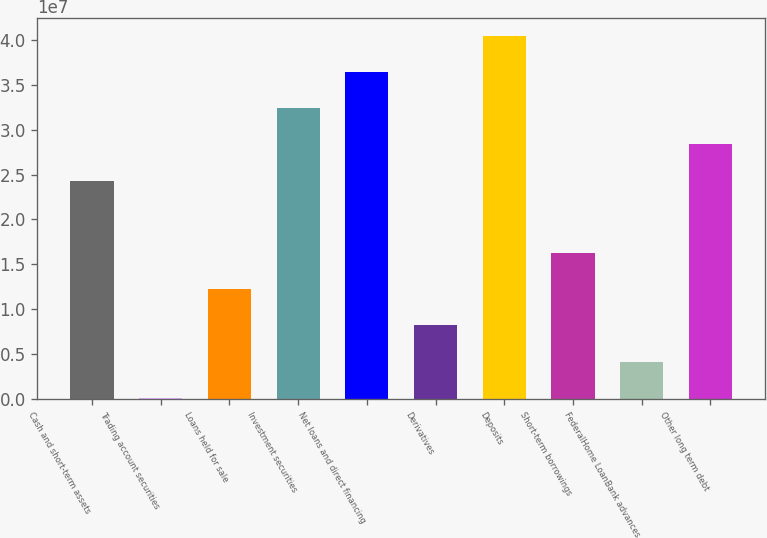Convert chart to OTSL. <chart><loc_0><loc_0><loc_500><loc_500><bar_chart><fcel>Cash and short-term assets<fcel>Trading account securities<fcel>Loans held for sale<fcel>Investment securities<fcel>Net loans and direct financing<fcel>Derivatives<fcel>Deposits<fcel>Short-term borrowings<fcel>FederalHome LoanBank advances<fcel>Other long term debt<nl><fcel>2.43298e+07<fcel>83657<fcel>1.22067e+07<fcel>3.24119e+07<fcel>3.64529e+07<fcel>8.16571e+06<fcel>4.04939e+07<fcel>1.62478e+07<fcel>4.12468e+06<fcel>2.83708e+07<nl></chart> 